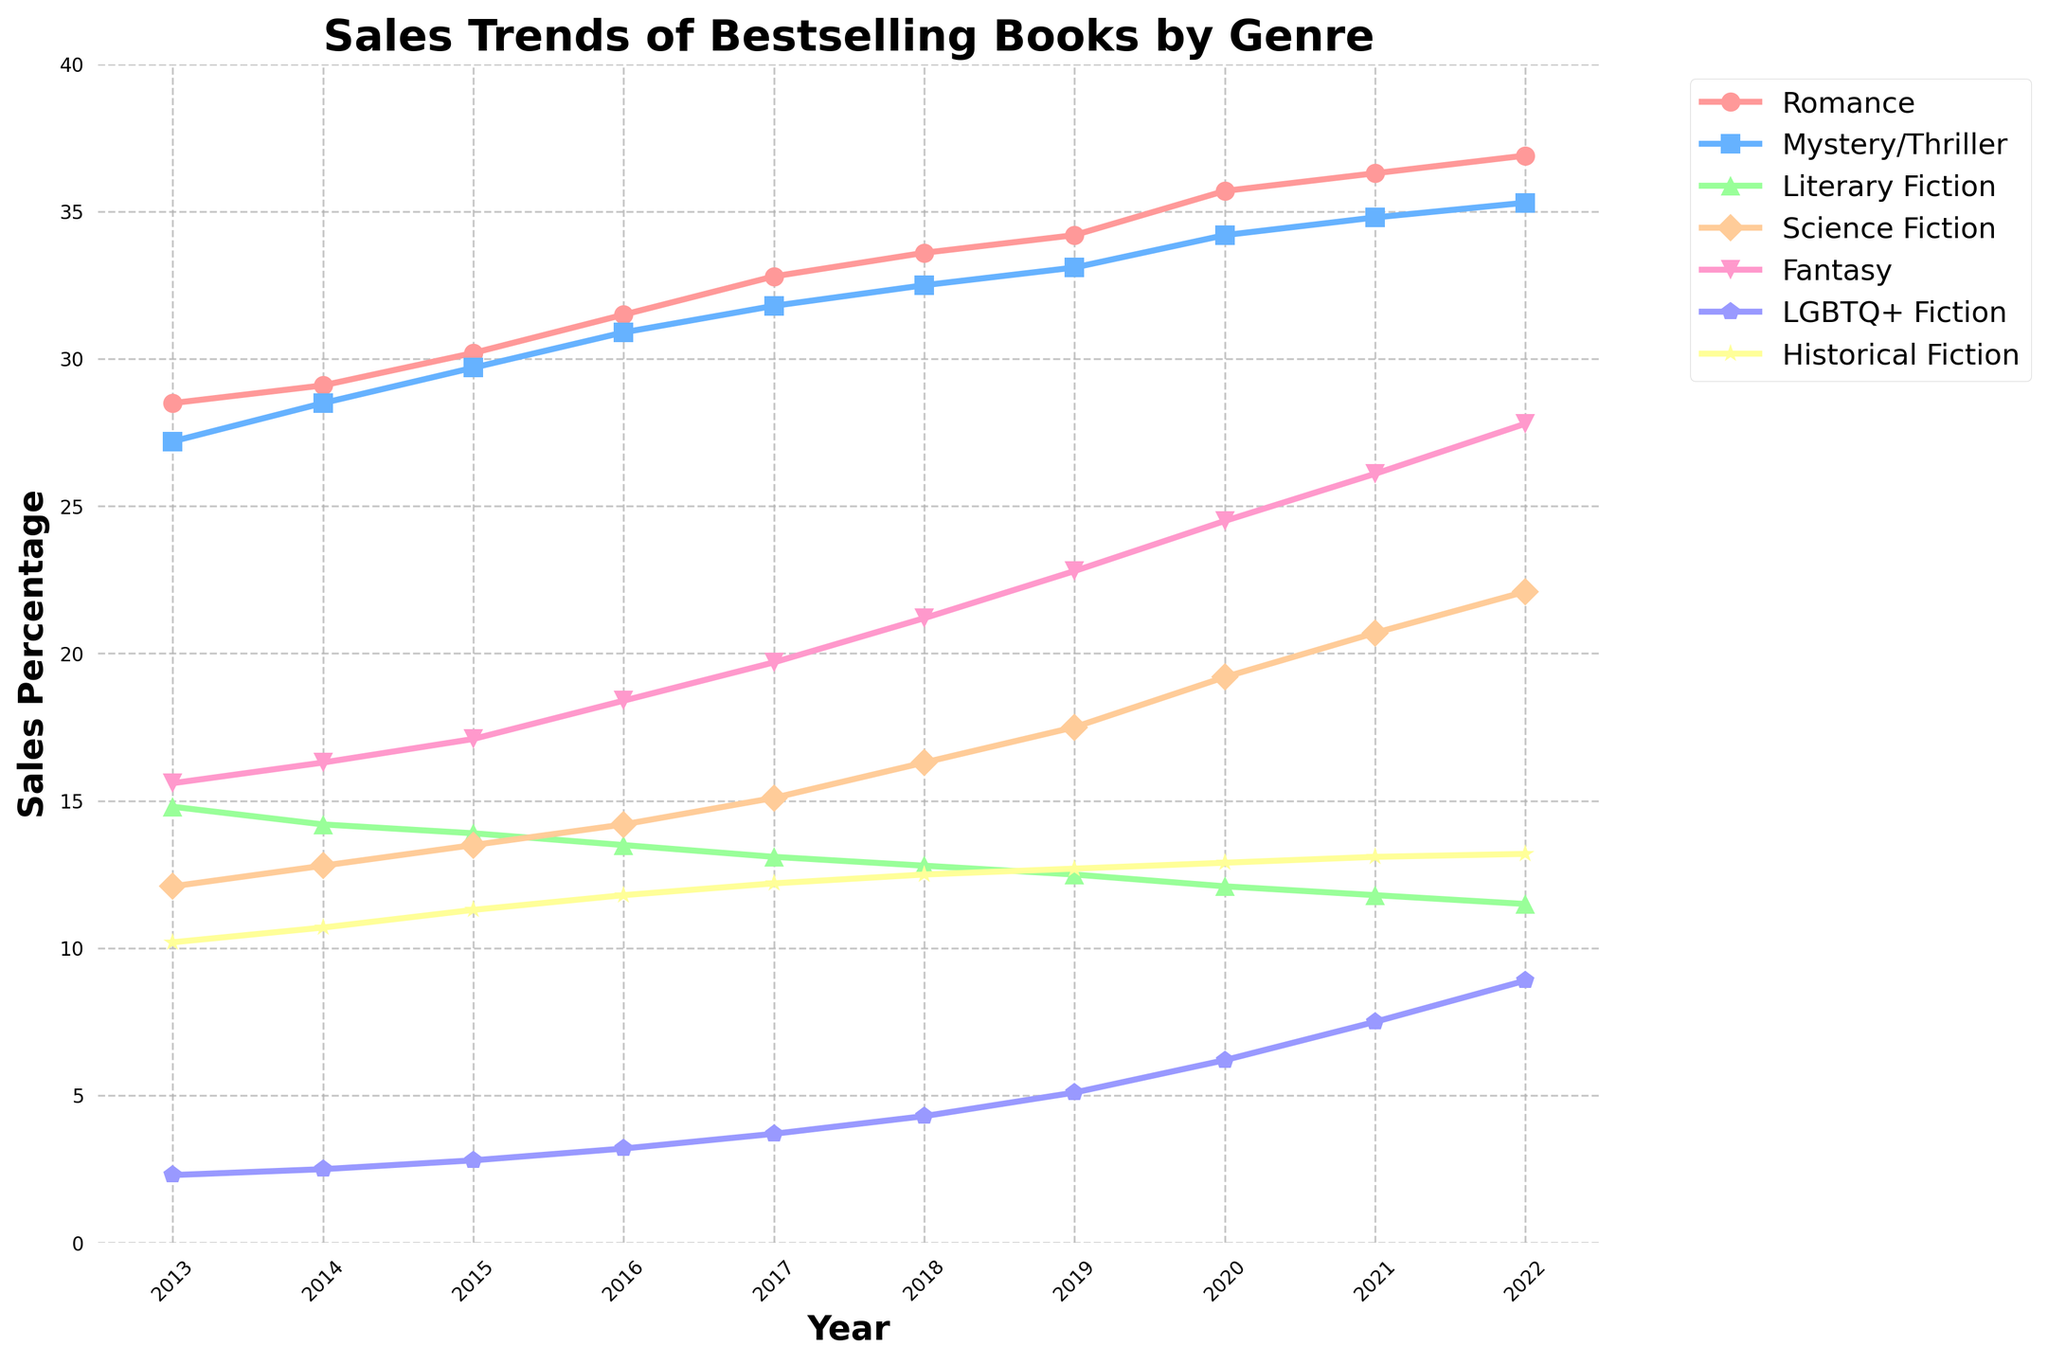Which genre experienced the highest increase in sales from 2013 to 2022? To determine the genre with the highest increase, subtract the 2013 sales percentage from the 2022 sales percentage for each genre. The differences are: Romance (36.9 - 28.5 = 8.4), Mystery/Thriller (35.3 - 27.2 = 8.1), Literary Fiction (11.5 - 14.8 = -3.3), Science Fiction (22.1 - 12.1 = 10.0), Fantasy (27.8 - 15.6 = 12.2), LGBTQ+ Fiction (8.9 - 2.3 = 6.6), Historical Fiction (13.2 - 10.2 = 3.0). Fantasy experienced the highest increase (12.2).
Answer: Fantasy Which genre had the lowest sales percentage in 2022? Look at the sales percentages for 2022 across all genres and find the minimum value. The sales percentages are: Romance (36.9), Mystery/Thriller (35.3), Literary Fiction (11.5), Science Fiction (22.1), Fantasy (27.8), LGBTQ+ Fiction (8.9), Historical Fiction (13.2). The lowest value is 8.9 for LGBTQ+ Fiction.
Answer: LGBTQ+ Fiction How did the sales percentage for Romance compare to Mystery/Thriller in 2020? Identify the sales percentages for both genres in 2020. Romance sales were 35.7, and Mystery/Thriller sales were 34.2. Romance was higher.
Answer: Romance was higher What is the total combined sales percentage for Science Fiction and Fantasy in 2021? Locate the 2021 sales percentages for Science Fiction (20.7) and Fantasy (26.1). Sum the two percentages: 20.7 + 26.1 = 46.8.
Answer: 46.8 Which genre showed the most consistent increase over the decade? Analyze the data to see which genre's sales percentage consistently increased each year from 2013 to 2022 without any dips. Romance (28.5 to 36.9), Mystery/Thriller (27.2 to 35.3), Science Fiction (12.1 to 22.1), Fantasy (15.6 to 27.8), LGBTQ+ Fiction (2.3 to 8.9). Genres like Romance and Mystery/Thriller showed consistent increases but Fantasy had the highest increase consistently.
Answer: Romance Did any genre experience a decline in sales percentage over the decade? Check each genre's initial (2013) and final (2022) sales percentages to see if any decreased. Literary Fiction is the only genre where sales decreased from 14.8 in 2013 to 11.5 in 2022.
Answer: Literary Fiction Between which consecutive years did Science Fiction sales percentage rise the most? Calculate the year-over-year differences for Science Fiction: 2013-2014 (12.8 - 12.1 = 0.7), 2014-2015 (13.5 - 12.8 = 0.7), 2015-2016 (14.2 - 13.5 = 0.7), 2016-2017 (15.1 - 14.2 = 0.9), 2017-2018 (16.3 - 15.1 = 1.2), 2018-2019 (17.5 - 16.3 = 1.2), 2019-2020 (19.2 - 17.5 = 1.7), 2020-2021 (20.7 - 19.2 = 1.5), 2021-2022 (22.1 - 20.7 = 1.4). The biggest increase was from 2019-2020 (1.7).
Answer: 2019 to 2020 Which genre had a higher sales percentage in 2017: Historical Fiction or LGBTQ+ Fiction? Compare the two genres' sales percentages in 2017. Historical Fiction was 12.2, and LGBTQ+ Fiction was 3.7. Historical Fiction was higher.
Answer: Historical Fiction What was the combined sales percentage for Mystery/Thriller and Fantasy in 2018? Add the sales percentages for Mystery/Thriller (32.5) and Fantasy (21.2) in 2018. 32.5 + 21.2 = 53.7.
Answer: 53.7 By how much did the sales percentage for LGBTQ+ Fiction increase from 2019 to 2022? Determine the sales percentages for LGBTQ+ Fiction in 2019 (5.1) and 2022 (8.9). Subtract the 2019 value from the 2022 value: 8.9 - 5.1 = 3.8.
Answer: 3.8 